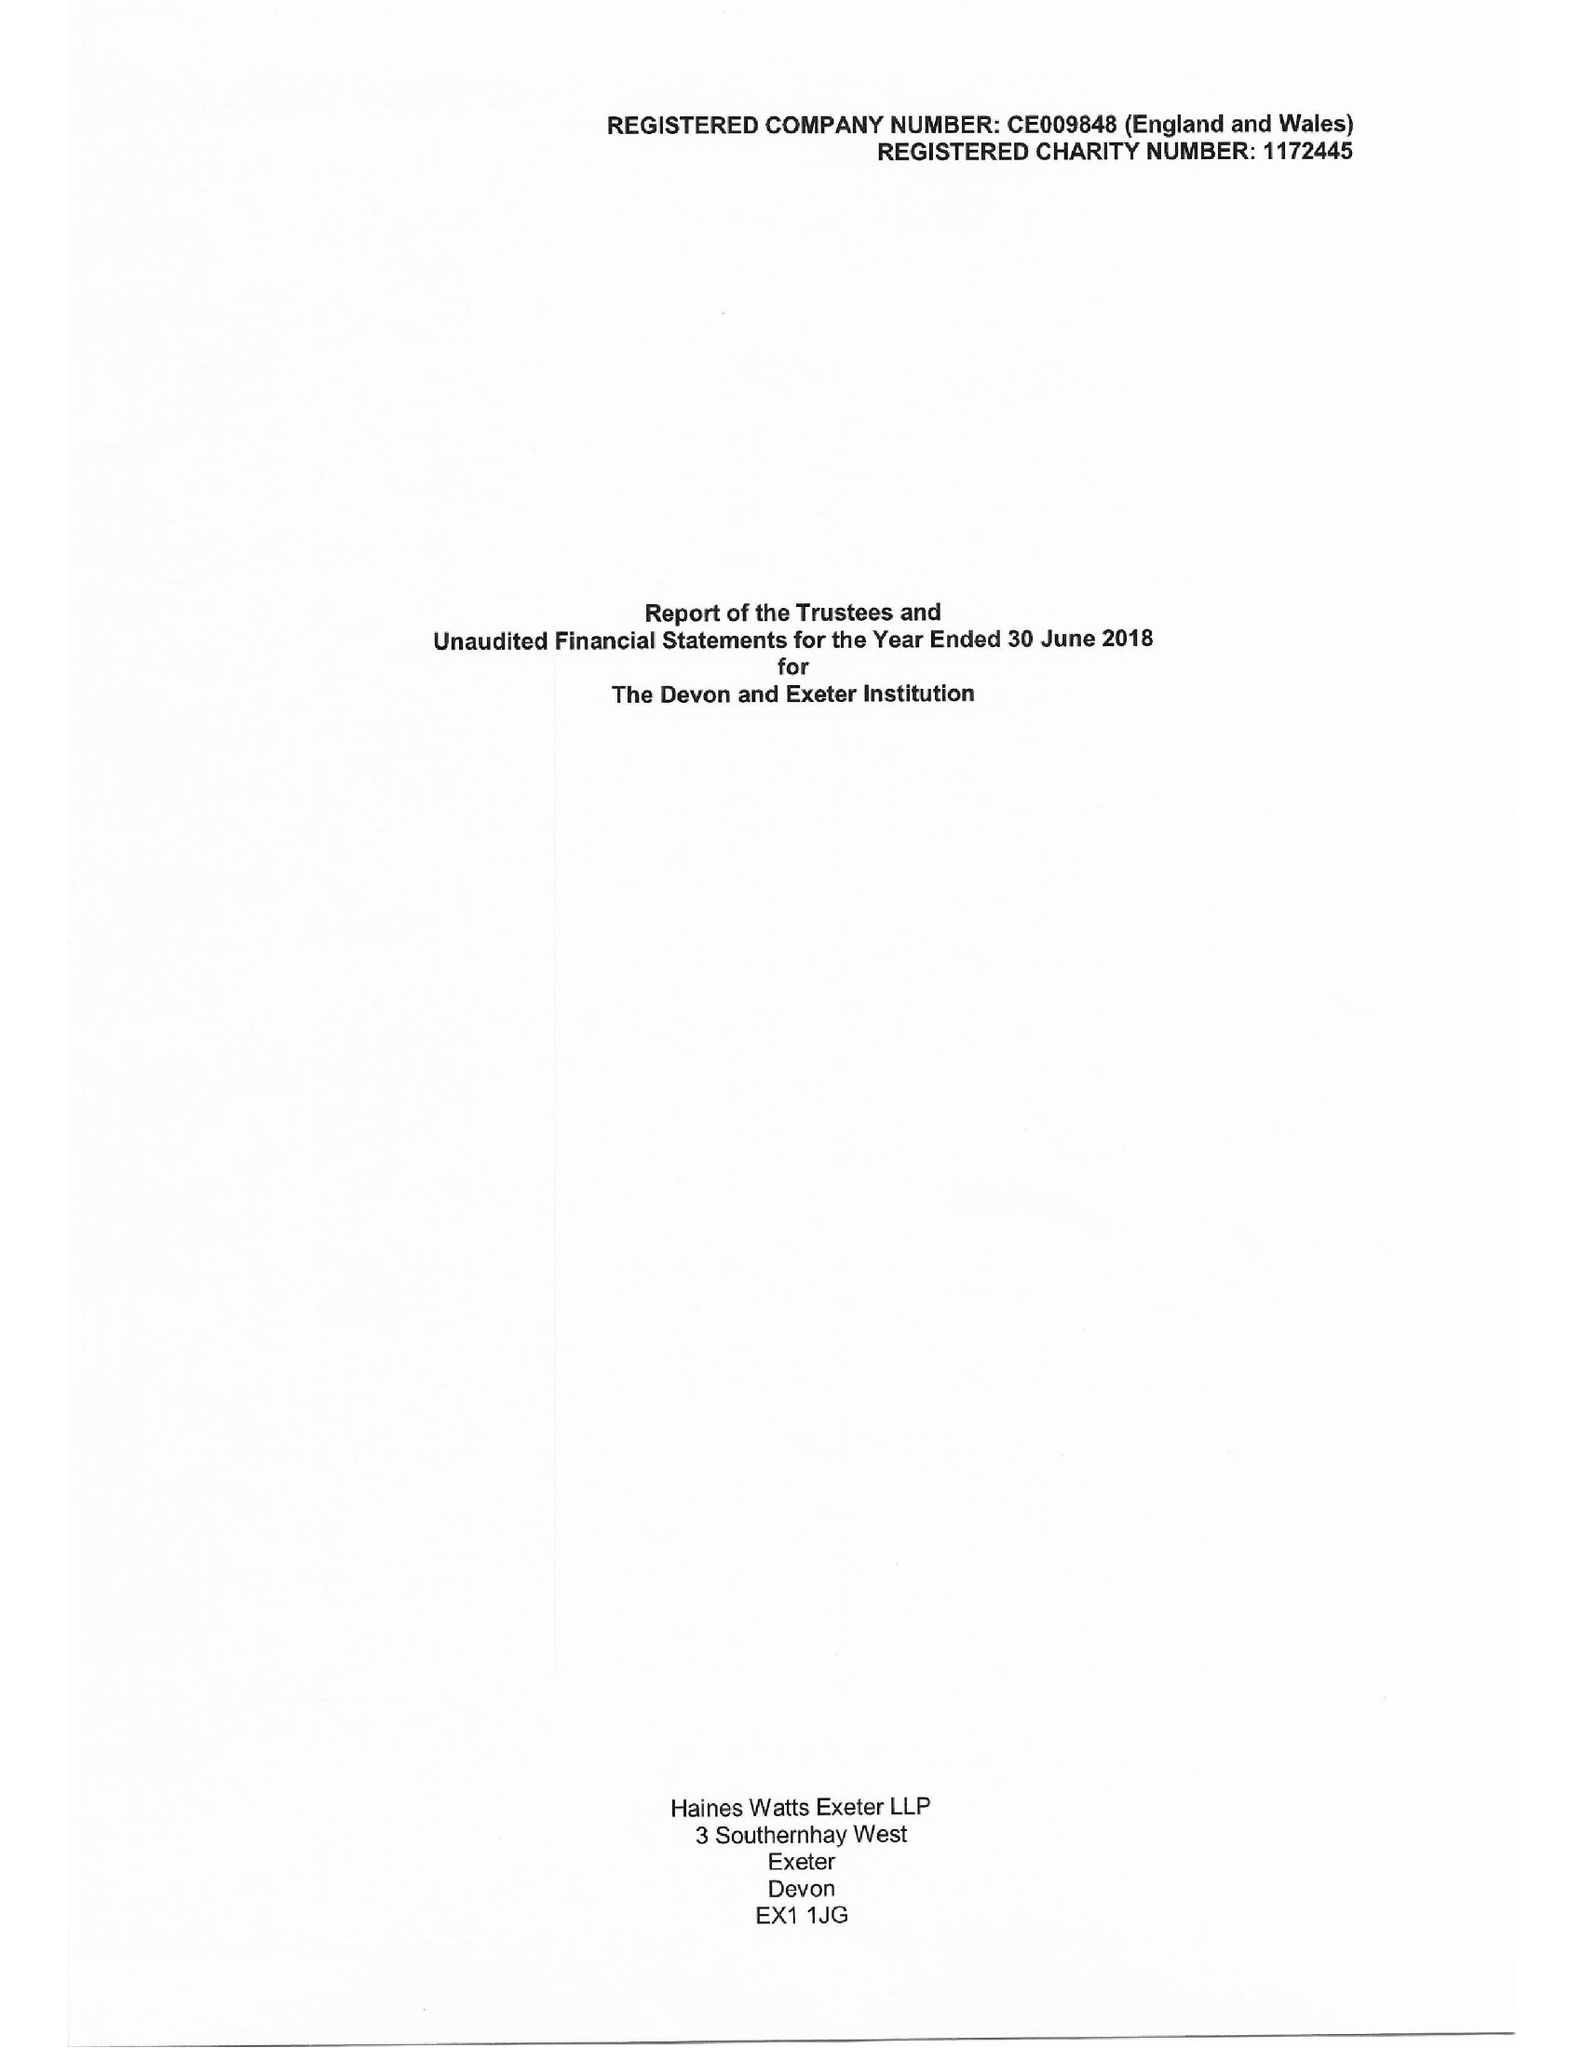What is the value for the charity_number?
Answer the question using a single word or phrase. 1172445 